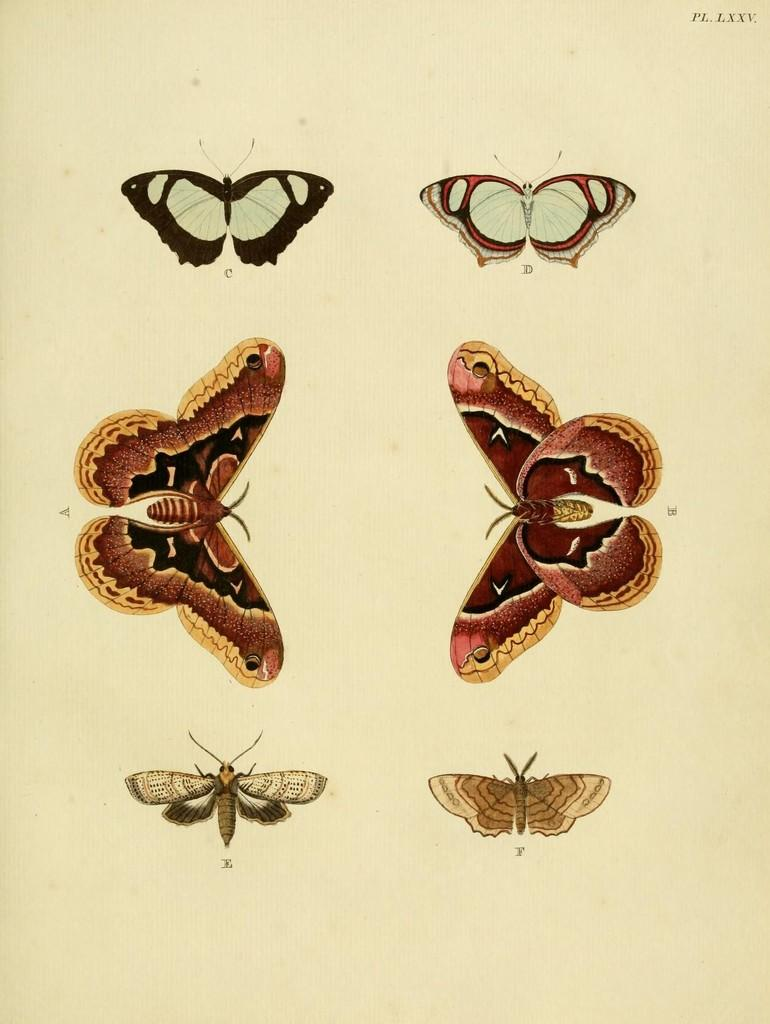What is the main subject of the image? The image contains a page. What is depicted on the page? The page displays types of butterflies. What is the name of the downtown area mentioned in the image? There is no mention of a downtown area in the image; it only displays types of butterflies. How does the image convey the concept of love? The image does not convey the concept of love; it only displays types of butterflies. 